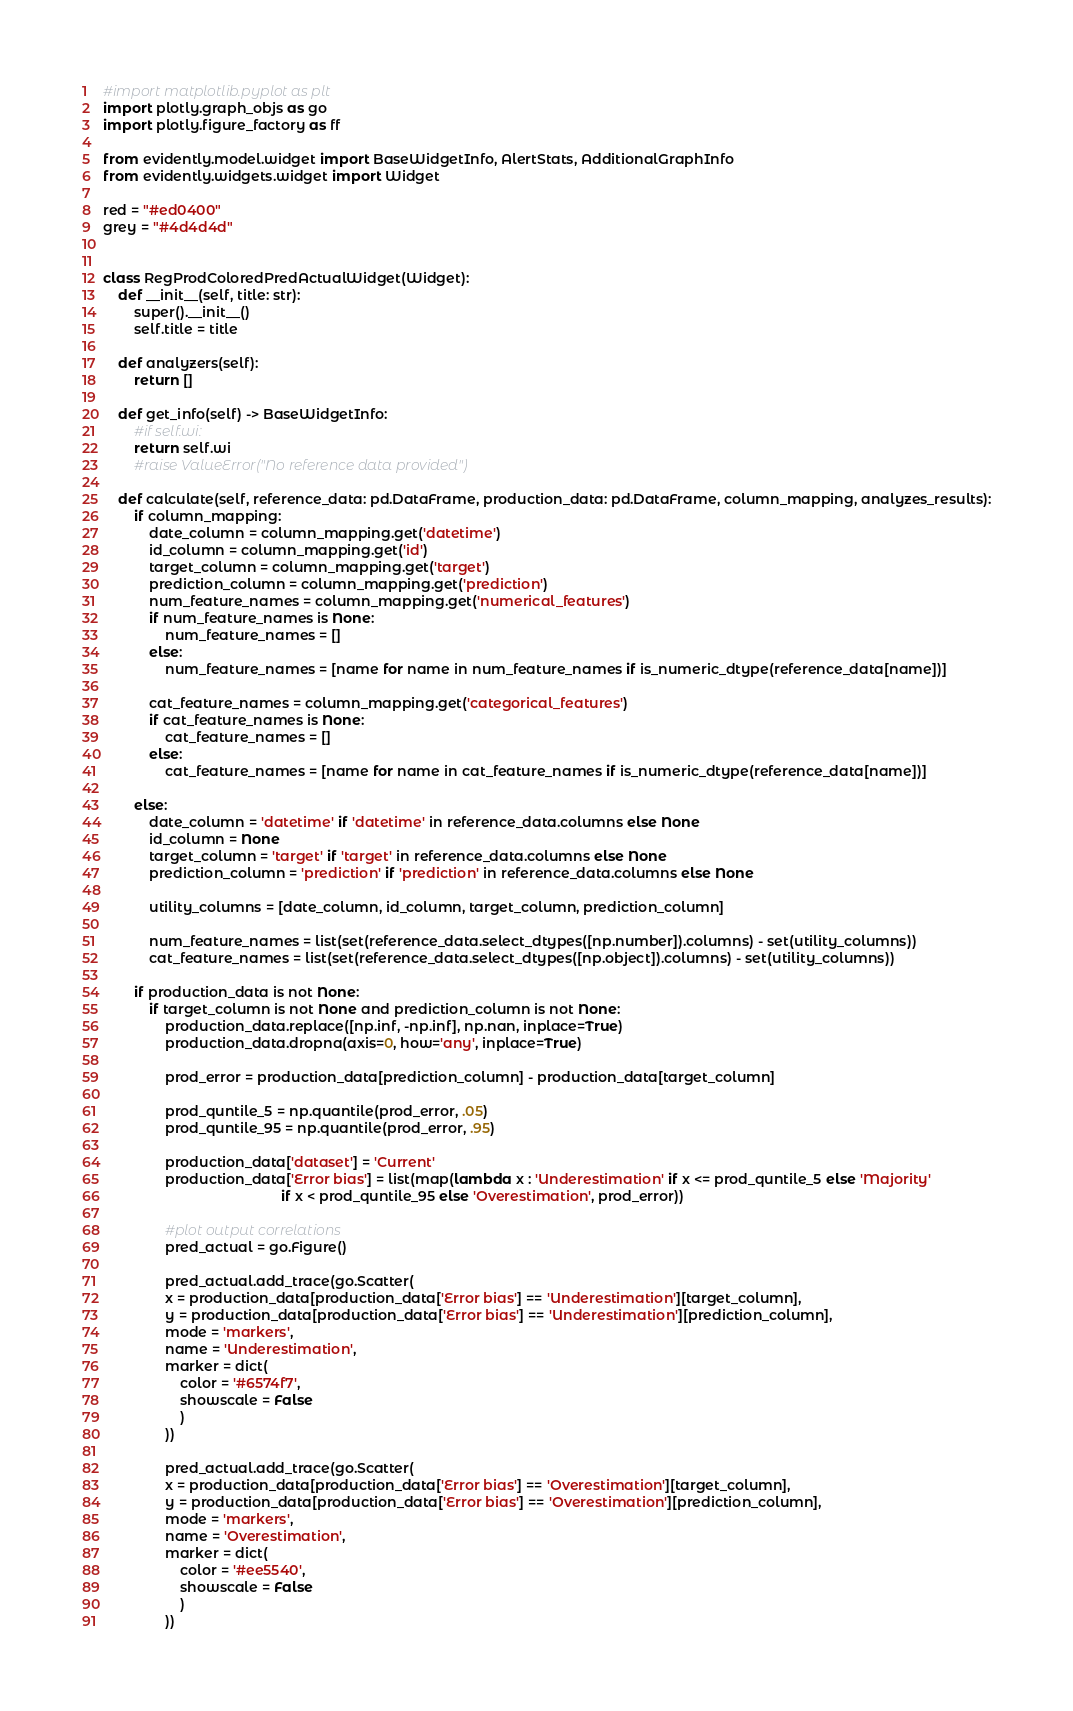Convert code to text. <code><loc_0><loc_0><loc_500><loc_500><_Python_>#import matplotlib.pyplot as plt
import plotly.graph_objs as go
import plotly.figure_factory as ff

from evidently.model.widget import BaseWidgetInfo, AlertStats, AdditionalGraphInfo
from evidently.widgets.widget import Widget

red = "#ed0400"
grey = "#4d4d4d"


class RegProdColoredPredActualWidget(Widget):
    def __init__(self, title: str):
        super().__init__()
        self.title = title

    def analyzers(self):
        return []

    def get_info(self) -> BaseWidgetInfo:
        #if self.wi:
        return self.wi
        #raise ValueError("No reference data provided")

    def calculate(self, reference_data: pd.DataFrame, production_data: pd.DataFrame, column_mapping, analyzes_results):
        if column_mapping:
            date_column = column_mapping.get('datetime')
            id_column = column_mapping.get('id')
            target_column = column_mapping.get('target')
            prediction_column = column_mapping.get('prediction')
            num_feature_names = column_mapping.get('numerical_features')
            if num_feature_names is None:
                num_feature_names = []
            else:
                num_feature_names = [name for name in num_feature_names if is_numeric_dtype(reference_data[name])] 

            cat_feature_names = column_mapping.get('categorical_features')
            if cat_feature_names is None:
                cat_feature_names = []
            else:
                cat_feature_names = [name for name in cat_feature_names if is_numeric_dtype(reference_data[name])] 
        
        else:
            date_column = 'datetime' if 'datetime' in reference_data.columns else None
            id_column = None
            target_column = 'target' if 'target' in reference_data.columns else None
            prediction_column = 'prediction' if 'prediction' in reference_data.columns else None

            utility_columns = [date_column, id_column, target_column, prediction_column]

            num_feature_names = list(set(reference_data.select_dtypes([np.number]).columns) - set(utility_columns))
            cat_feature_names = list(set(reference_data.select_dtypes([np.object]).columns) - set(utility_columns))

        if production_data is not None:
            if target_column is not None and prediction_column is not None:
                production_data.replace([np.inf, -np.inf], np.nan, inplace=True)
                production_data.dropna(axis=0, how='any', inplace=True)

                prod_error = production_data[prediction_column] - production_data[target_column]

                prod_quntile_5 = np.quantile(prod_error, .05)
                prod_quntile_95 = np.quantile(prod_error, .95)

                production_data['dataset'] = 'Current'
                production_data['Error bias'] = list(map(lambda x : 'Underestimation' if x <= prod_quntile_5 else 'Majority' 
                                              if x < prod_quntile_95 else 'Overestimation', prod_error))
                
                #plot output correlations
                pred_actual = go.Figure()

                pred_actual.add_trace(go.Scatter(
                x = production_data[production_data['Error bias'] == 'Underestimation'][target_column],
                y = production_data[production_data['Error bias'] == 'Underestimation'][prediction_column],
                mode = 'markers',
                name = 'Underestimation',
                marker = dict(
                    color = '#6574f7',
                    showscale = False
                    )
                ))

                pred_actual.add_trace(go.Scatter(
                x = production_data[production_data['Error bias'] == 'Overestimation'][target_column],
                y = production_data[production_data['Error bias'] == 'Overestimation'][prediction_column],
                mode = 'markers',
                name = 'Overestimation',
                marker = dict(
                    color = '#ee5540',
                    showscale = False
                    )
                ))
</code> 